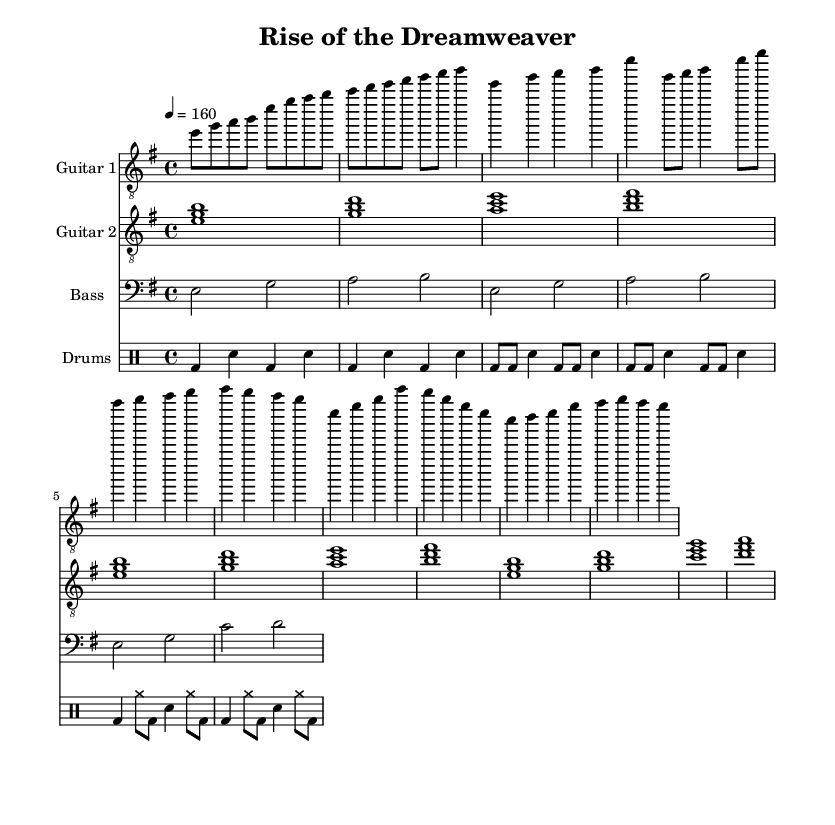What is the key signature of this music? The key signature is E minor, which has one sharp (F#). This can be determined by observing the key signature at the beginning of the staff.
Answer: E minor What is the time signature of this music? The time signature is 4/4, which is indicated at the beginning of the score. This means there are four beats in each measure, and the quarter note gets one beat.
Answer: 4/4 What is the tempo marking of this music? The tempo marking is 160 beats per minute (BPM), indicated by the numerical value next to the tempo indication. This sets the speed at which the piece should be played.
Answer: 160 How many measures are in the chorus section? The chorus section contains four measures. By counting the number of measures explicitly notated under the chorus section in the score, we can determine the total.
Answer: 4 What type of guitar clef is used for Guitar 1? Guitar 1 uses the treble clef, which is indicated at the beginning of the staff for that part. This clef is common for instruments that play higher pitches.
Answer: Treble Which instrument plays the bass line? The bass line is played by the bass instrument, which is indicated at the beginning of that staff with "Bass." This part provides the harmonic foundation and depth to the arrangement.
Answer: Bass What rhythmic pattern is introduced in the intro section of the drums? The rhythmic pattern in the intro features a kick drum followed by a snare. Each measure alternates between the bass drum and snare, creating a driving rhythm typical in metal music.
Answer: Kick-Snare 